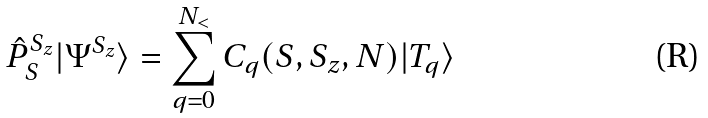<formula> <loc_0><loc_0><loc_500><loc_500>\hat { P } _ { S } ^ { S _ { z } } | \Psi ^ { S _ { z } } \rangle = \sum _ { q = 0 } ^ { N _ { < } } C _ { q } ( S , S _ { z } , N ) | T _ { q } \rangle</formula> 